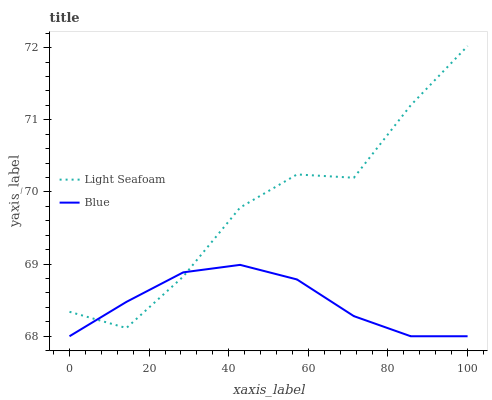Does Light Seafoam have the minimum area under the curve?
Answer yes or no. No. Is Light Seafoam the smoothest?
Answer yes or no. No. Does Light Seafoam have the lowest value?
Answer yes or no. No. 